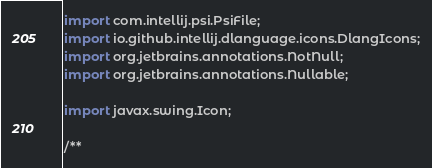Convert code to text. <code><loc_0><loc_0><loc_500><loc_500><_Java_>import com.intellij.psi.PsiFile;
import io.github.intellij.dlanguage.icons.DlangIcons;
import org.jetbrains.annotations.NotNull;
import org.jetbrains.annotations.Nullable;

import javax.swing.Icon;

/**</code> 